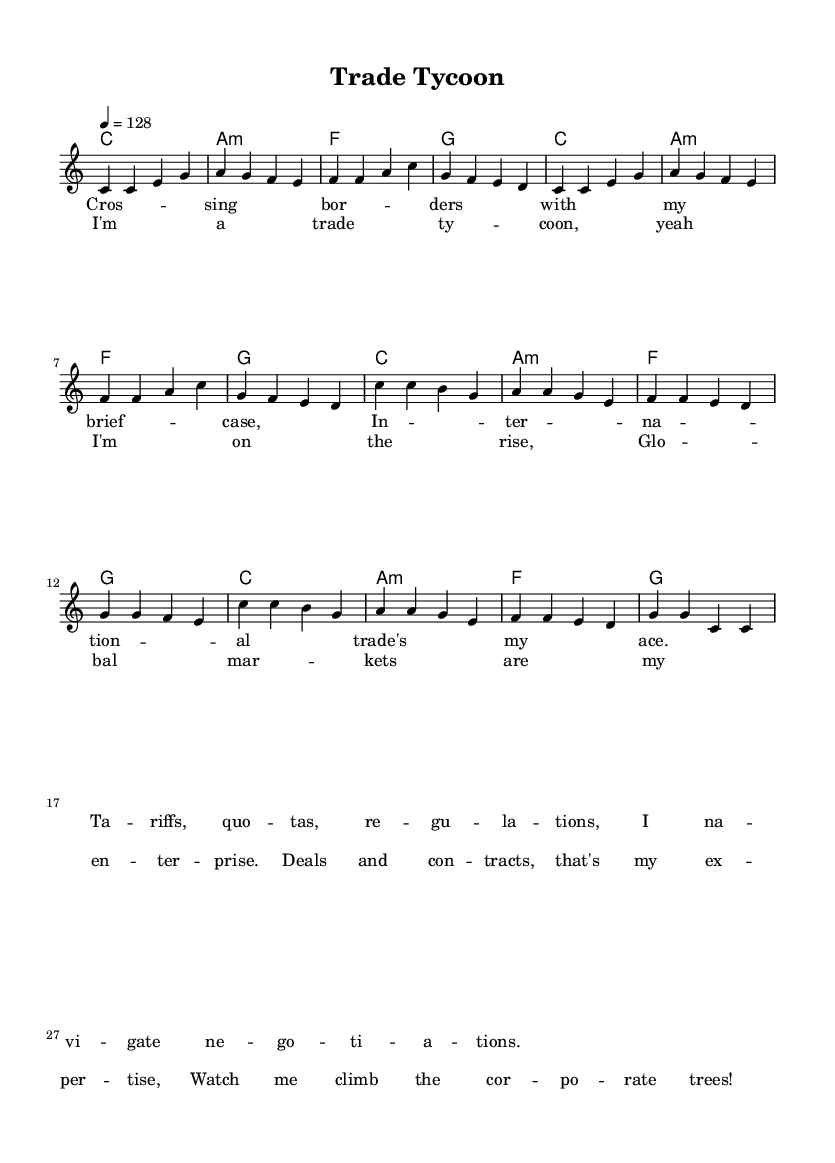What is the key signature of this music? The key signature is C major, indicated at the beginning of the score. It shows there are no sharps or flats.
Answer: C major What is the time signature of this music? The time signature is 4/4, as shown at the beginning of the score. This means there are four beats in each measure and the quarter note gets one beat.
Answer: 4/4 What is the tempo of the piece? The tempo marking is 128 bpm, indicated by the tempo of 4 = 128. This means it is played at 128 beats per minute.
Answer: 128 How many measures are in the verse section? The verse section consists of 8 measures, as counted in the melody part where it repeats the same pattern.
Answer: 8 In what section do you find the lyrics about 'corporate trees'? The lyrics about 'corporate trees' are found in the chorus section, as indicated by the lyrics following the melody.
Answer: Chorus What type of chord is used in measure 3? In measure 3, the chord is F major, as specified in the harmonies section of the sheet music.
Answer: F What musical genre does this piece represent? The piece falls under the pop genre, due to its upbeat rhythm and lighthearted lyrics related to financial success and business acumen.
Answer: Pop 